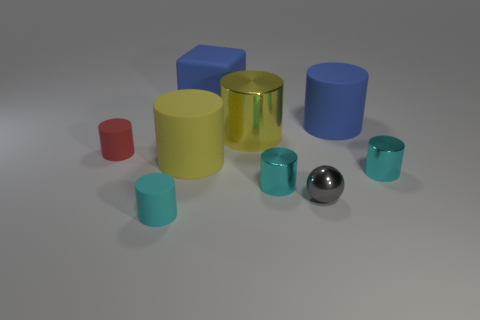There is a blue block left of the big blue rubber cylinder; is it the same size as the matte cylinder that is in front of the gray thing?
Give a very brief answer. No. How many objects are either big blue objects that are right of the large matte cube or small brown objects?
Your response must be concise. 1. Are there fewer large blue shiny objects than large yellow things?
Ensure brevity in your answer.  Yes. There is a big thing in front of the thing left of the cylinder in front of the gray metallic ball; what is its shape?
Ensure brevity in your answer.  Cylinder. There is a large object that is the same color as the big block; what is its shape?
Provide a succinct answer. Cylinder. Is there a big brown rubber sphere?
Your answer should be very brief. No. There is a cube; does it have the same size as the yellow object behind the small red cylinder?
Offer a very short reply. Yes. There is a rubber thing on the right side of the blue block; is there a thing that is behind it?
Offer a terse response. Yes. What is the big object that is behind the big yellow matte thing and in front of the blue cylinder made of?
Keep it short and to the point. Metal. There is a rubber thing that is behind the rubber cylinder behind the tiny rubber cylinder that is on the left side of the tiny cyan rubber cylinder; what color is it?
Offer a very short reply. Blue. 